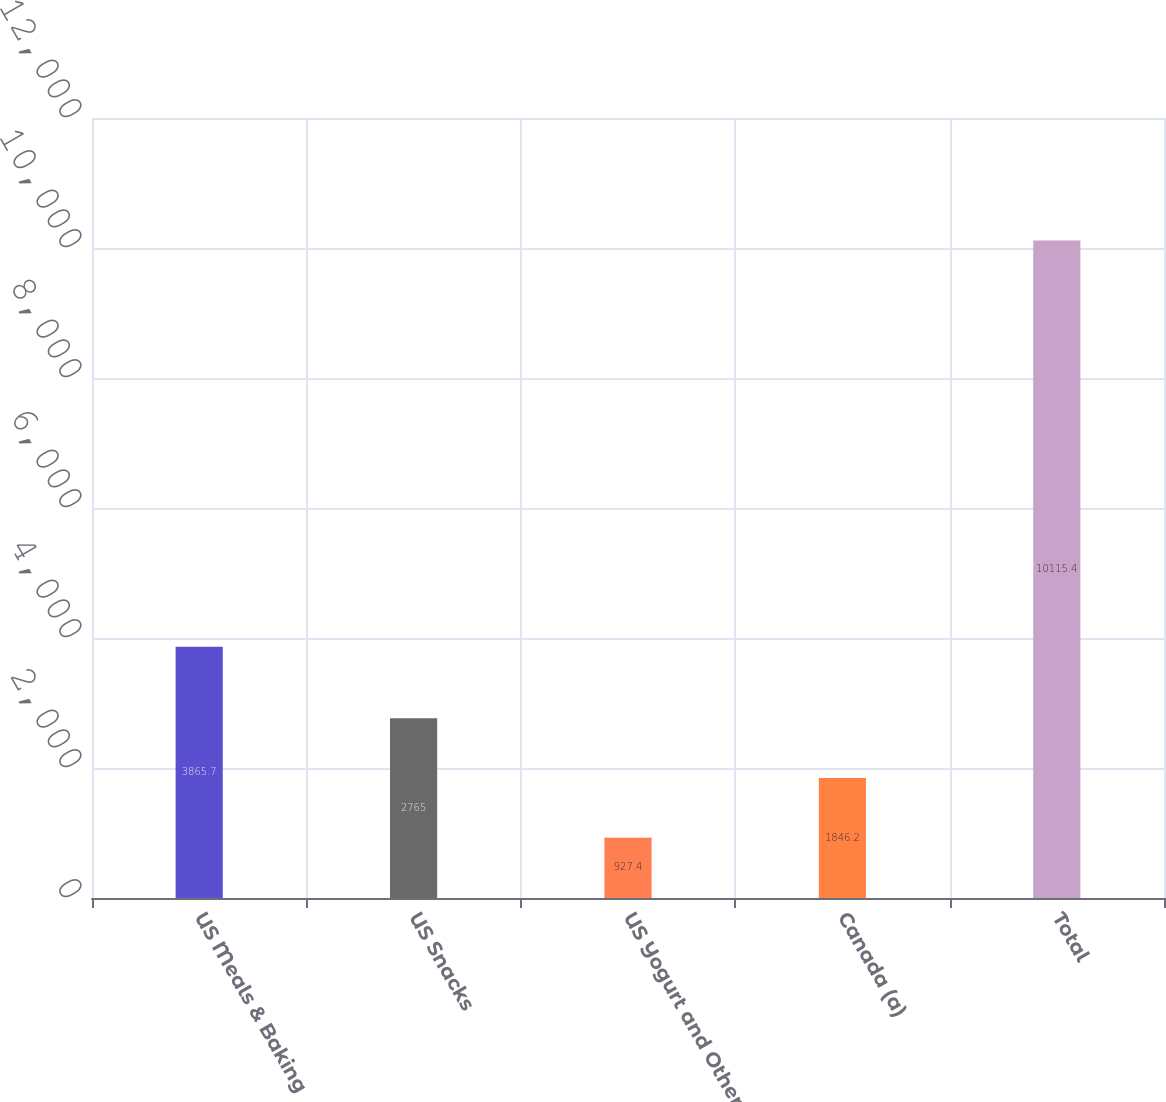<chart> <loc_0><loc_0><loc_500><loc_500><bar_chart><fcel>US Meals & Baking<fcel>US Snacks<fcel>US Yogurt and Other<fcel>Canada (a)<fcel>Total<nl><fcel>3865.7<fcel>2765<fcel>927.4<fcel>1846.2<fcel>10115.4<nl></chart> 